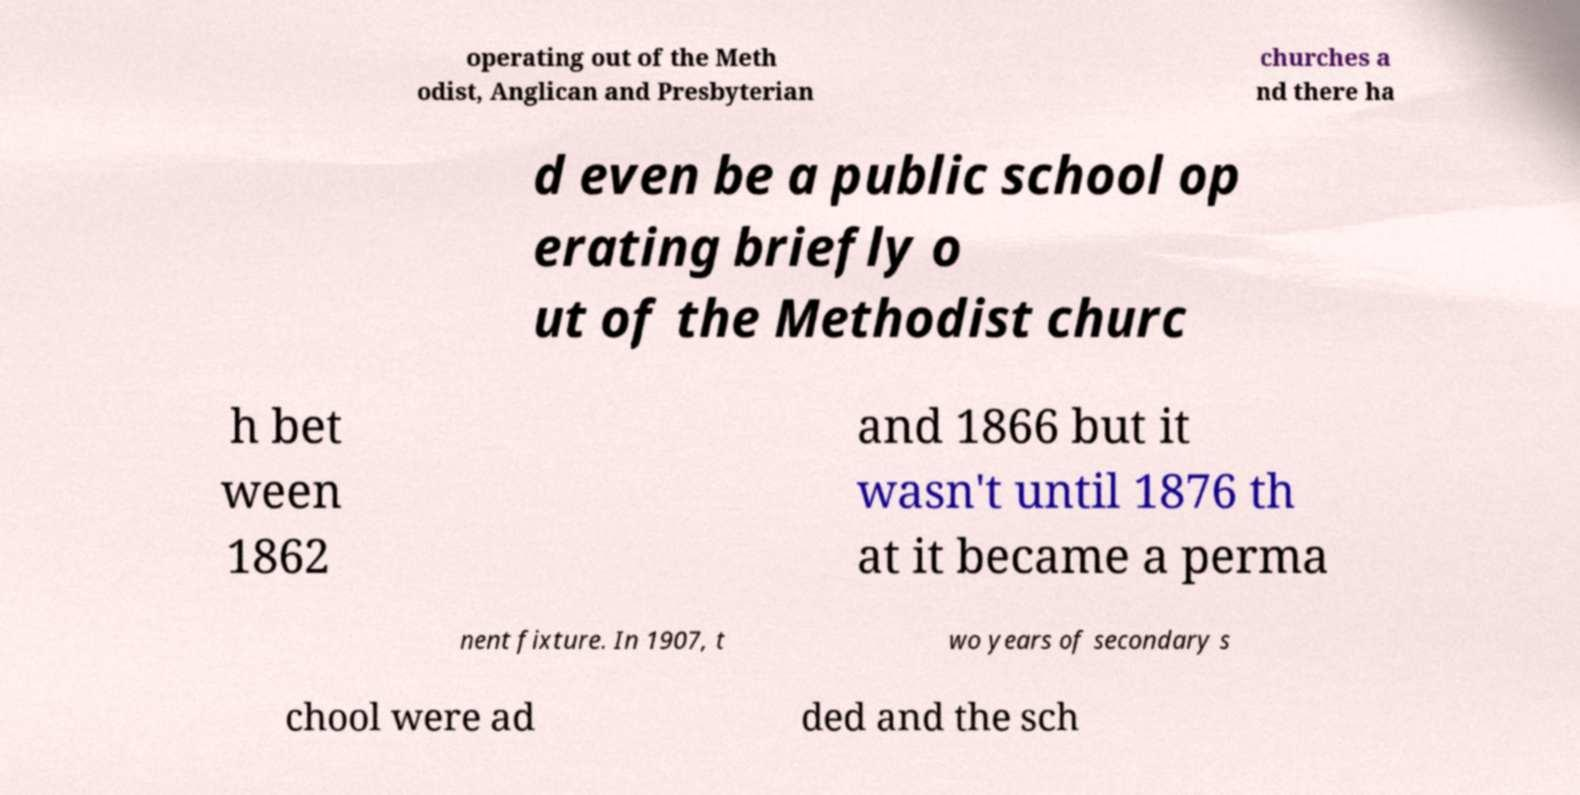I need the written content from this picture converted into text. Can you do that? operating out of the Meth odist, Anglican and Presbyterian churches a nd there ha d even be a public school op erating briefly o ut of the Methodist churc h bet ween 1862 and 1866 but it wasn't until 1876 th at it became a perma nent fixture. In 1907, t wo years of secondary s chool were ad ded and the sch 